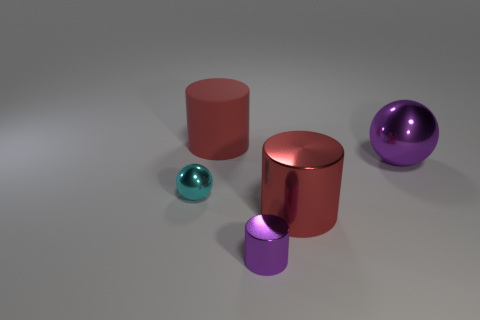What number of large purple cubes are made of the same material as the tiny purple cylinder?
Your response must be concise. 0. How many large things are on the right side of the big cylinder that is left of the large cylinder in front of the matte object?
Your answer should be very brief. 2. Do the small purple shiny thing and the big red metal object have the same shape?
Your answer should be compact. Yes. Are there any tiny objects that have the same shape as the big purple metallic object?
Make the answer very short. Yes. There is another red thing that is the same size as the matte thing; what is its shape?
Provide a short and direct response. Cylinder. What is the material of the red cylinder left of the red cylinder that is in front of the ball that is on the left side of the big shiny cylinder?
Give a very brief answer. Rubber. Do the cyan metallic object and the red rubber cylinder have the same size?
Ensure brevity in your answer.  No. There is a big thing that is the same color as the big shiny cylinder; what is it made of?
Provide a short and direct response. Rubber. Is the shape of the large red object that is in front of the red matte object the same as  the large purple metallic thing?
Your response must be concise. No. What number of things are metal things or red rubber objects?
Your response must be concise. 5. 